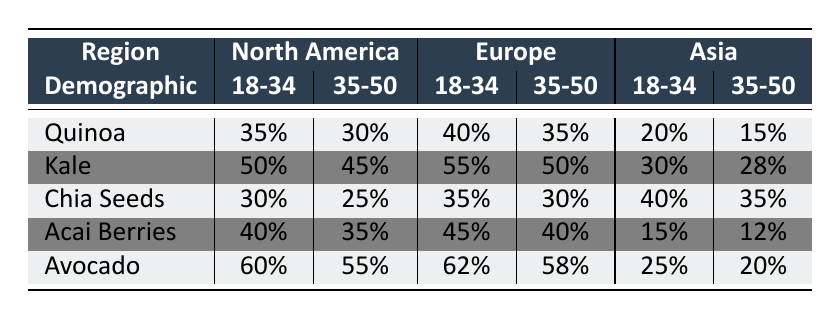What is the highest consumption rate of Acai Berries in North America? The highest consumption rate of Acai Berries in North America can be found by comparing the percentages listed for different demographics. For Adults (18-34), the consumption is 40%, and for Adults (35-50) it is 35%. Therefore, the highest is 40% for Adults (18-34).
Answer: 40% Which demographic in Europe consumes the most Kale? By examining the table, the consumption rates of Kale in Europe are 55% for Adults (18-34), 50% for Adults (35-50), and 45% for Seniors (51+). The highest consumption is 55% for Adults (18-34).
Answer: 55% Is the consumption of Avocado among Seniors (51+) in Asia higher than that among Adults (35-50)? The table shows Avocado consumption for Seniors (51+) in Asia is 18% and for Adults (35-50) it is 20%. Since 18% is less than 20%, the statement is false.
Answer: No Calculate the average consumption rate of Chia Seeds for Adults (18-34) across all regions. The consumption rates for Chia Seeds among Adults (18-34) are 30% (North America), 35% (Europe), and 40% (Asia). To find the average, add them up: 30 + 35 + 40 = 105, then divide by 3 (number of regions): 105 / 3 = 35%.
Answer: 35% Which region shows the greatest difference in Quinoa consumption between the 18-34 and 35-50 demographic groups? In North America, the difference is 5% (35% for 18-34, 30% for 35-50). In Europe, the difference is 5% (40% for 18-34, 35% for 35-50). In Asia, the difference is 5% (20% for 18-34, 15% for 35-50). All regions have the same difference of 5%. Therefore, there is no region that shows a greater difference than others.
Answer: 5% 